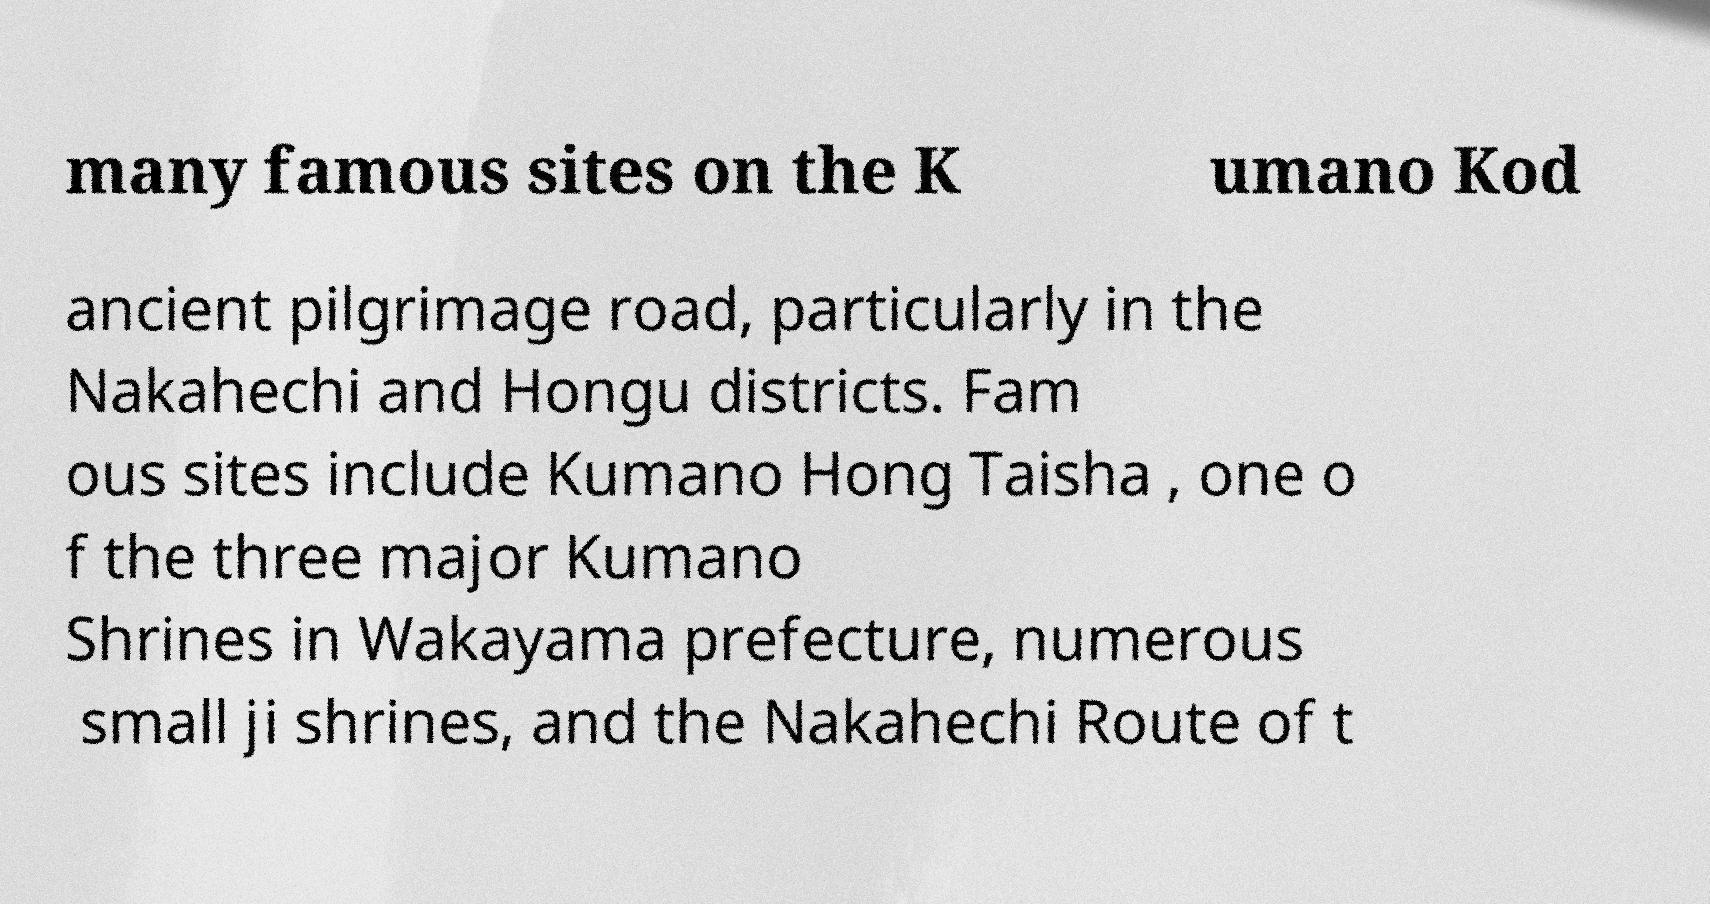I need the written content from this picture converted into text. Can you do that? many famous sites on the K umano Kod ancient pilgrimage road, particularly in the Nakahechi and Hongu districts. Fam ous sites include Kumano Hong Taisha , one o f the three major Kumano Shrines in Wakayama prefecture, numerous small ji shrines, and the Nakahechi Route of t 